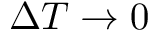<formula> <loc_0><loc_0><loc_500><loc_500>\Delta T \rightarrow 0</formula> 